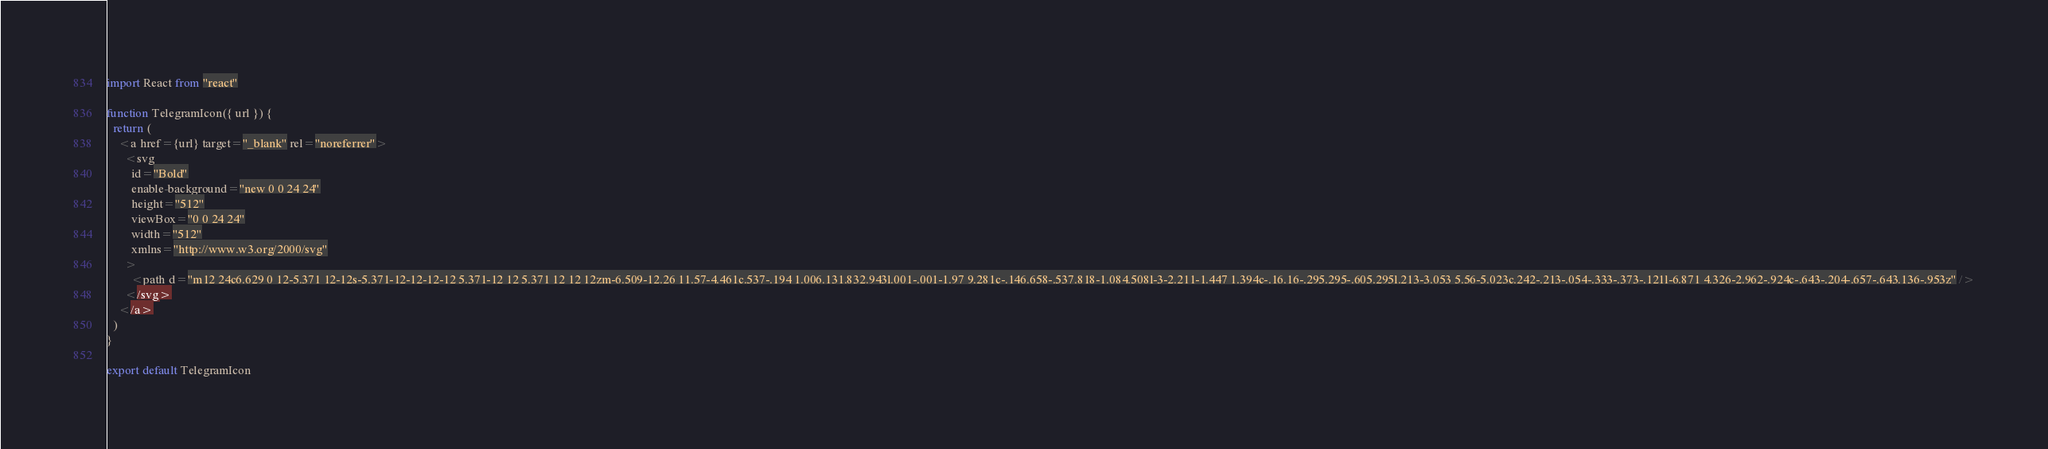Convert code to text. <code><loc_0><loc_0><loc_500><loc_500><_JavaScript_>import React from "react"

function TelegramIcon({ url }) {
  return (
    <a href={url} target="_blank" rel="noreferrer">
      <svg
        id="Bold"
        enable-background="new 0 0 24 24"
        height="512"
        viewBox="0 0 24 24"
        width="512"
        xmlns="http://www.w3.org/2000/svg"
      >
        <path d="m12 24c6.629 0 12-5.371 12-12s-5.371-12-12-12-12 5.371-12 12 5.371 12 12 12zm-6.509-12.26 11.57-4.461c.537-.194 1.006.131.832.943l.001-.001-1.97 9.281c-.146.658-.537.818-1.084.508l-3-2.211-1.447 1.394c-.16.16-.295.295-.605.295l.213-3.053 5.56-5.023c.242-.213-.054-.333-.373-.121l-6.871 4.326-2.962-.924c-.643-.204-.657-.643.136-.953z" />
      </svg>
    </a>
  )
}

export default TelegramIcon
</code> 